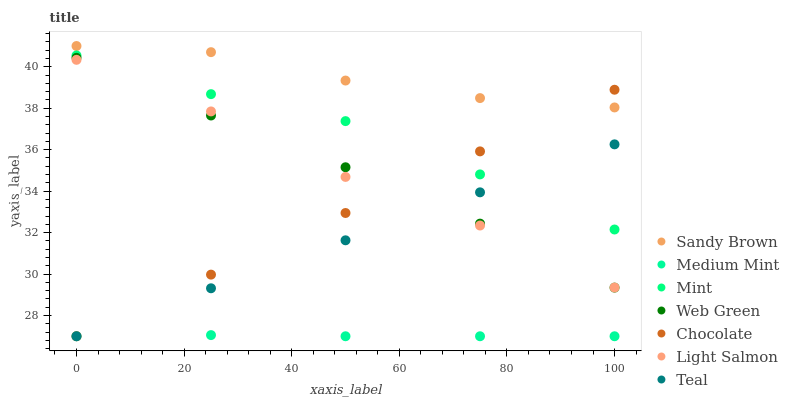Does Medium Mint have the minimum area under the curve?
Answer yes or no. Yes. Does Sandy Brown have the maximum area under the curve?
Answer yes or no. Yes. Does Light Salmon have the minimum area under the curve?
Answer yes or no. No. Does Light Salmon have the maximum area under the curve?
Answer yes or no. No. Is Teal the smoothest?
Answer yes or no. Yes. Is Light Salmon the roughest?
Answer yes or no. Yes. Is Sandy Brown the smoothest?
Answer yes or no. No. Is Sandy Brown the roughest?
Answer yes or no. No. Does Medium Mint have the lowest value?
Answer yes or no. Yes. Does Light Salmon have the lowest value?
Answer yes or no. No. Does Sandy Brown have the highest value?
Answer yes or no. Yes. Does Light Salmon have the highest value?
Answer yes or no. No. Is Medium Mint less than Sandy Brown?
Answer yes or no. Yes. Is Mint greater than Web Green?
Answer yes or no. Yes. Does Teal intersect Chocolate?
Answer yes or no. Yes. Is Teal less than Chocolate?
Answer yes or no. No. Is Teal greater than Chocolate?
Answer yes or no. No. Does Medium Mint intersect Sandy Brown?
Answer yes or no. No. 